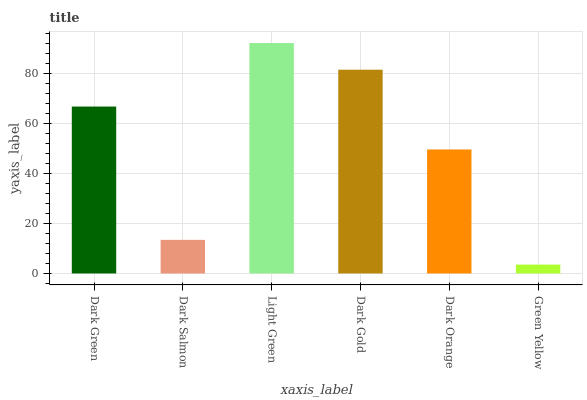Is Green Yellow the minimum?
Answer yes or no. Yes. Is Light Green the maximum?
Answer yes or no. Yes. Is Dark Salmon the minimum?
Answer yes or no. No. Is Dark Salmon the maximum?
Answer yes or no. No. Is Dark Green greater than Dark Salmon?
Answer yes or no. Yes. Is Dark Salmon less than Dark Green?
Answer yes or no. Yes. Is Dark Salmon greater than Dark Green?
Answer yes or no. No. Is Dark Green less than Dark Salmon?
Answer yes or no. No. Is Dark Green the high median?
Answer yes or no. Yes. Is Dark Orange the low median?
Answer yes or no. Yes. Is Dark Orange the high median?
Answer yes or no. No. Is Light Green the low median?
Answer yes or no. No. 